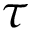<formula> <loc_0><loc_0><loc_500><loc_500>\tau</formula> 